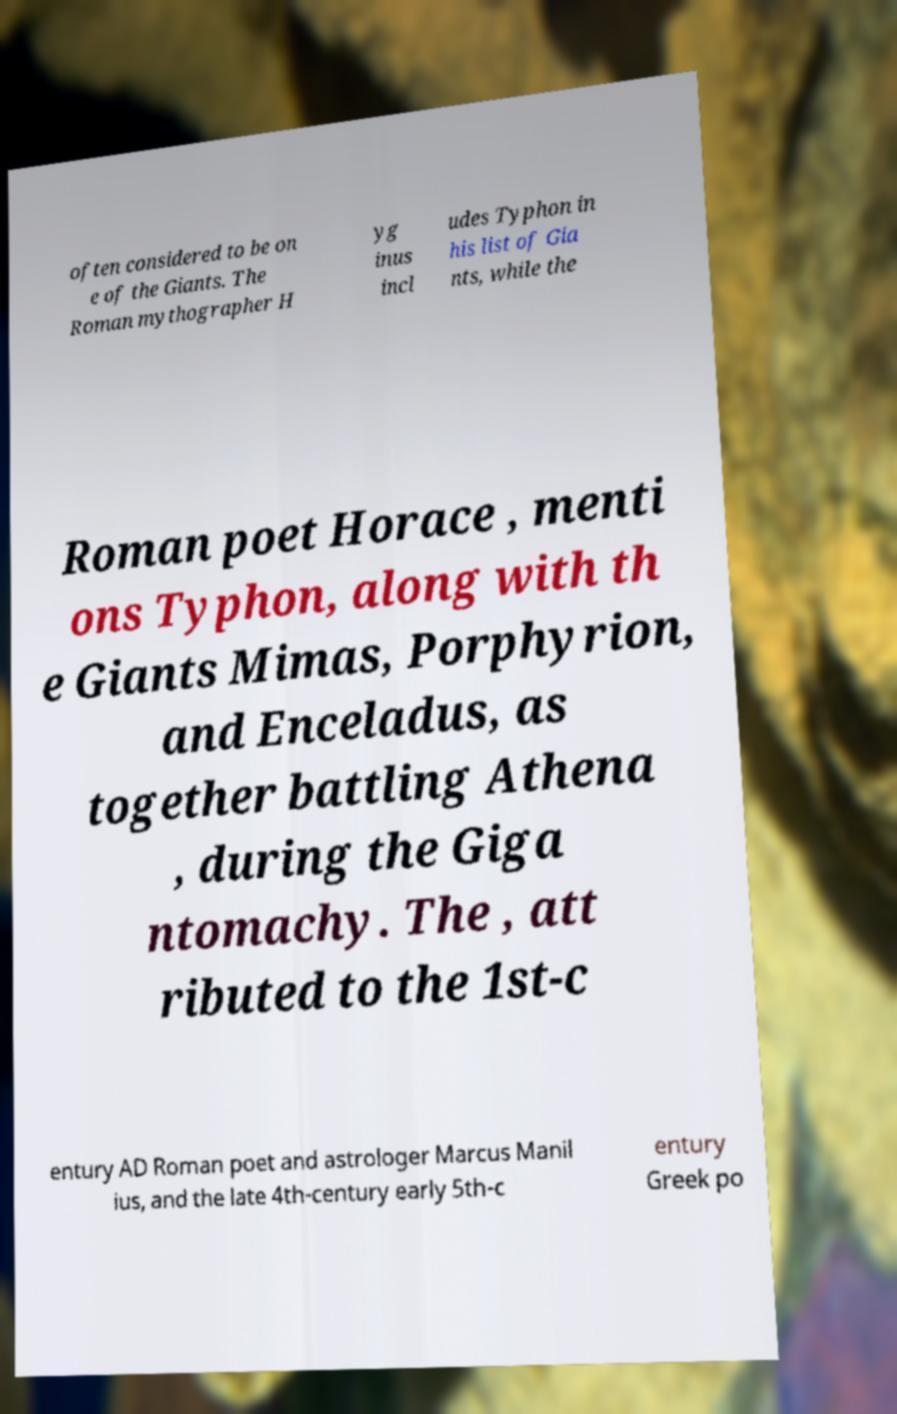There's text embedded in this image that I need extracted. Can you transcribe it verbatim? often considered to be on e of the Giants. The Roman mythographer H yg inus incl udes Typhon in his list of Gia nts, while the Roman poet Horace , menti ons Typhon, along with th e Giants Mimas, Porphyrion, and Enceladus, as together battling Athena , during the Giga ntomachy. The , att ributed to the 1st-c entury AD Roman poet and astrologer Marcus Manil ius, and the late 4th-century early 5th-c entury Greek po 